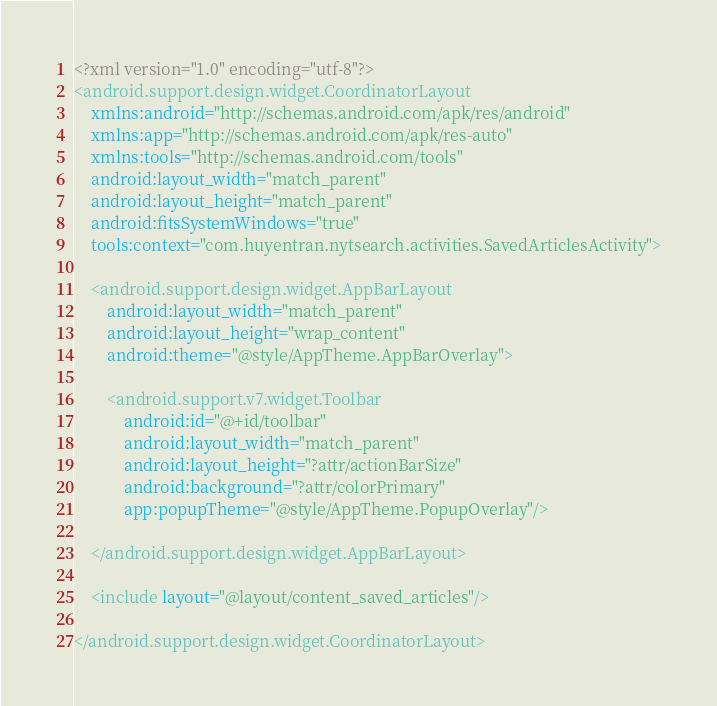<code> <loc_0><loc_0><loc_500><loc_500><_XML_><?xml version="1.0" encoding="utf-8"?>
<android.support.design.widget.CoordinatorLayout
    xmlns:android="http://schemas.android.com/apk/res/android"
    xmlns:app="http://schemas.android.com/apk/res-auto"
    xmlns:tools="http://schemas.android.com/tools"
    android:layout_width="match_parent"
    android:layout_height="match_parent"
    android:fitsSystemWindows="true"
    tools:context="com.huyentran.nytsearch.activities.SavedArticlesActivity">

    <android.support.design.widget.AppBarLayout
        android:layout_width="match_parent"
        android:layout_height="wrap_content"
        android:theme="@style/AppTheme.AppBarOverlay">

        <android.support.v7.widget.Toolbar
            android:id="@+id/toolbar"
            android:layout_width="match_parent"
            android:layout_height="?attr/actionBarSize"
            android:background="?attr/colorPrimary"
            app:popupTheme="@style/AppTheme.PopupOverlay"/>

    </android.support.design.widget.AppBarLayout>

    <include layout="@layout/content_saved_articles"/>

</android.support.design.widget.CoordinatorLayout>
</code> 